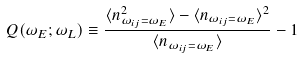Convert formula to latex. <formula><loc_0><loc_0><loc_500><loc_500>Q ( \omega _ { E } ; \omega _ { L } ) \equiv \frac { \langle n ^ { 2 } _ { \omega _ { i j } = \omega _ { E } } \rangle - \langle n _ { \omega _ { i j } = \omega _ { E } } \rangle ^ { 2 } } { \langle n _ { \omega _ { i j } = \omega _ { E } } \rangle } - 1</formula> 